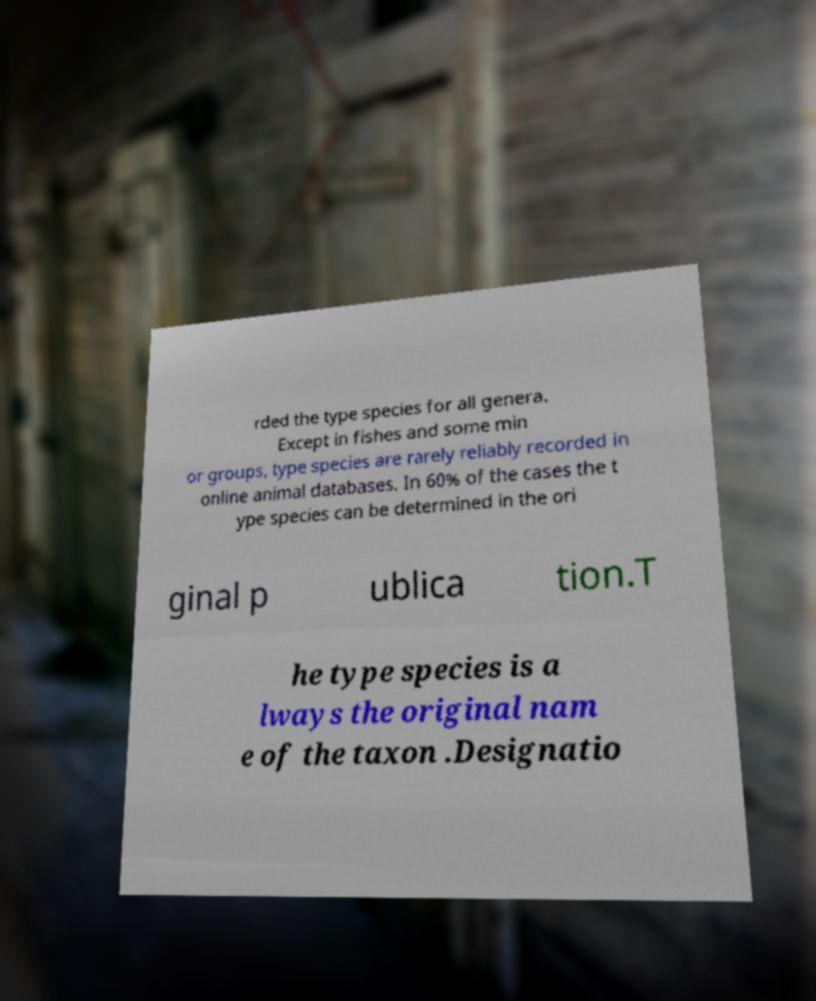Could you assist in decoding the text presented in this image and type it out clearly? rded the type species for all genera. Except in fishes and some min or groups, type species are rarely reliably recorded in online animal databases. In 60% of the cases the t ype species can be determined in the ori ginal p ublica tion.T he type species is a lways the original nam e of the taxon .Designatio 